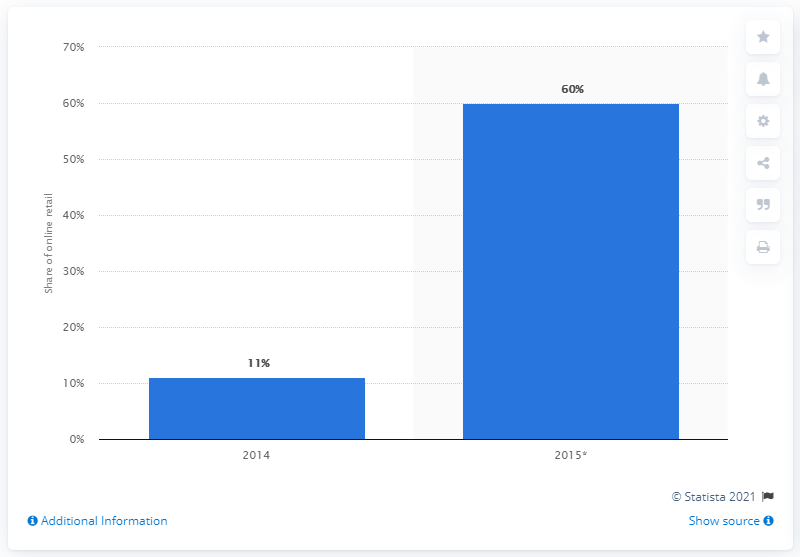List a handful of essential elements in this visual. In 2014, m-commerce accounted for approximately 11% of total retail sales. 